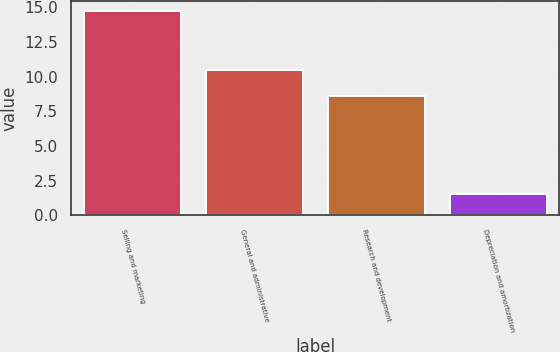Convert chart. <chart><loc_0><loc_0><loc_500><loc_500><bar_chart><fcel>Selling and marketing<fcel>General and administrative<fcel>Research and development<fcel>Depreciation and amortization<nl><fcel>14.7<fcel>10.5<fcel>8.6<fcel>1.5<nl></chart> 